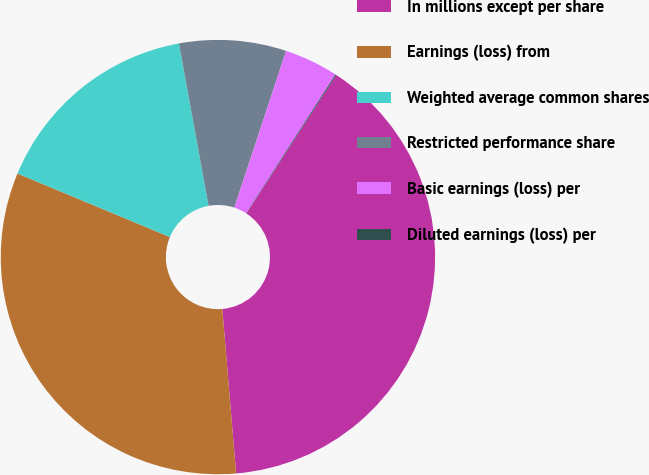Convert chart to OTSL. <chart><loc_0><loc_0><loc_500><loc_500><pie_chart><fcel>In millions except per share<fcel>Earnings (loss) from<fcel>Weighted average common shares<fcel>Restricted performance share<fcel>Basic earnings (loss) per<fcel>Diluted earnings (loss) per<nl><fcel>39.48%<fcel>32.62%<fcel>15.84%<fcel>7.96%<fcel>4.02%<fcel>0.08%<nl></chart> 